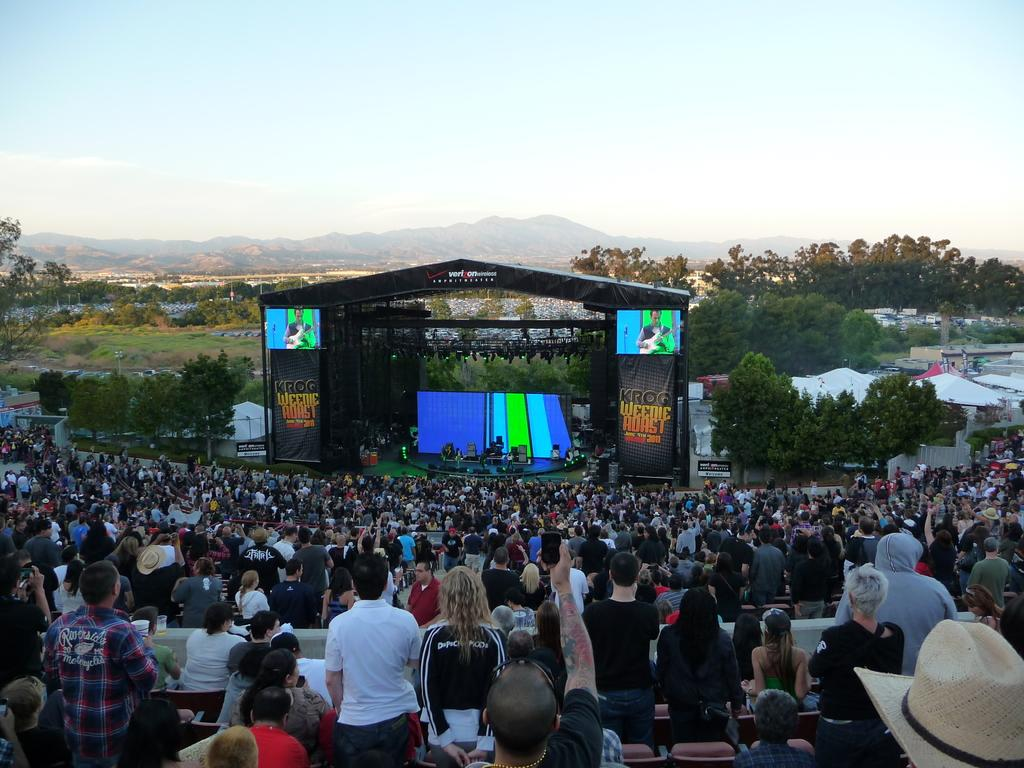What is the main subject of the image? The main subject of the image is a crowd. What can be seen in the background of the image? In the background of the image, there is a dais, trees, and mountains. What type of natural features are visible in the image? The image features trees and mountains in the background. What type of metal is being used to create trouble in the image? There is no mention of metal or trouble in the image; it features a crowd and a background with a dais, trees, and mountains. 